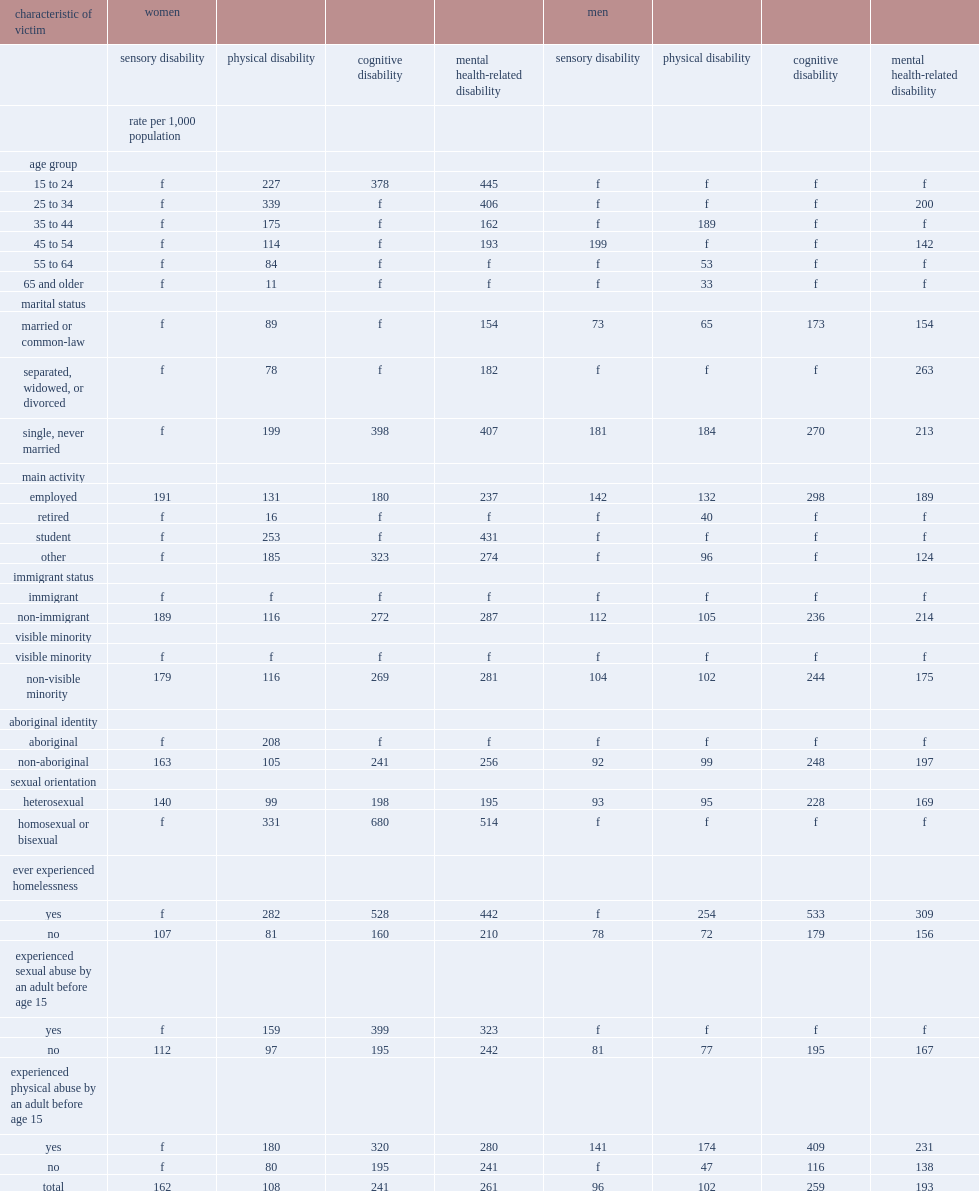How many incidents of violent victimization for every 1,000 women with a mental health-related disability between the ages of 15 and 24? 445.0. How many incidents of violent victimization for every 1,000 women with a mental health-related disability between the ages of 25 and 34? 406.0. How many incidents of violent victimization for every 1,000 women with a cognitive disability between the ages of 15 and 24? 378.0. 